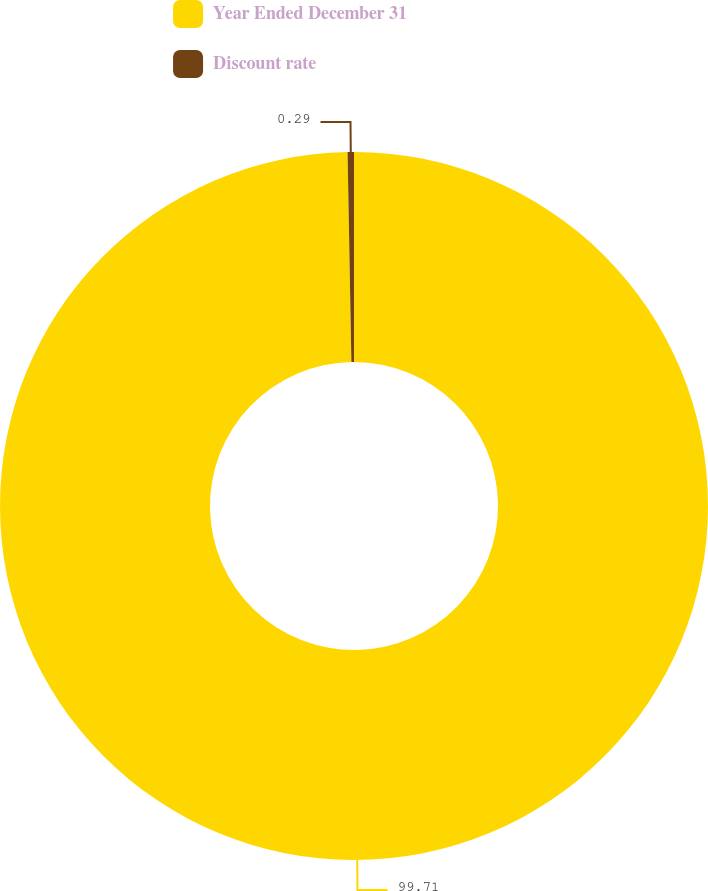Convert chart. <chart><loc_0><loc_0><loc_500><loc_500><pie_chart><fcel>Year Ended December 31<fcel>Discount rate<nl><fcel>99.71%<fcel>0.29%<nl></chart> 